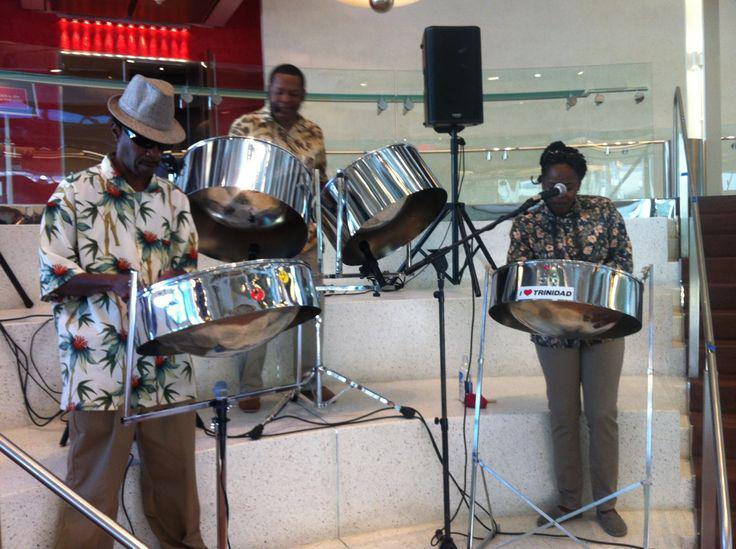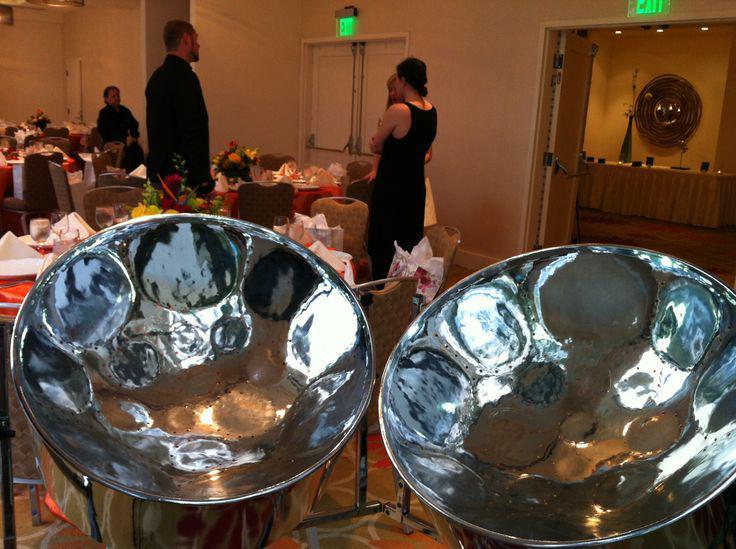The first image is the image on the left, the second image is the image on the right. Analyze the images presented: Is the assertion "The left image shows musicians standing behind no more than four steel drums, and exactly one musician is wearing a fedora hat." valid? Answer yes or no. Yes. 